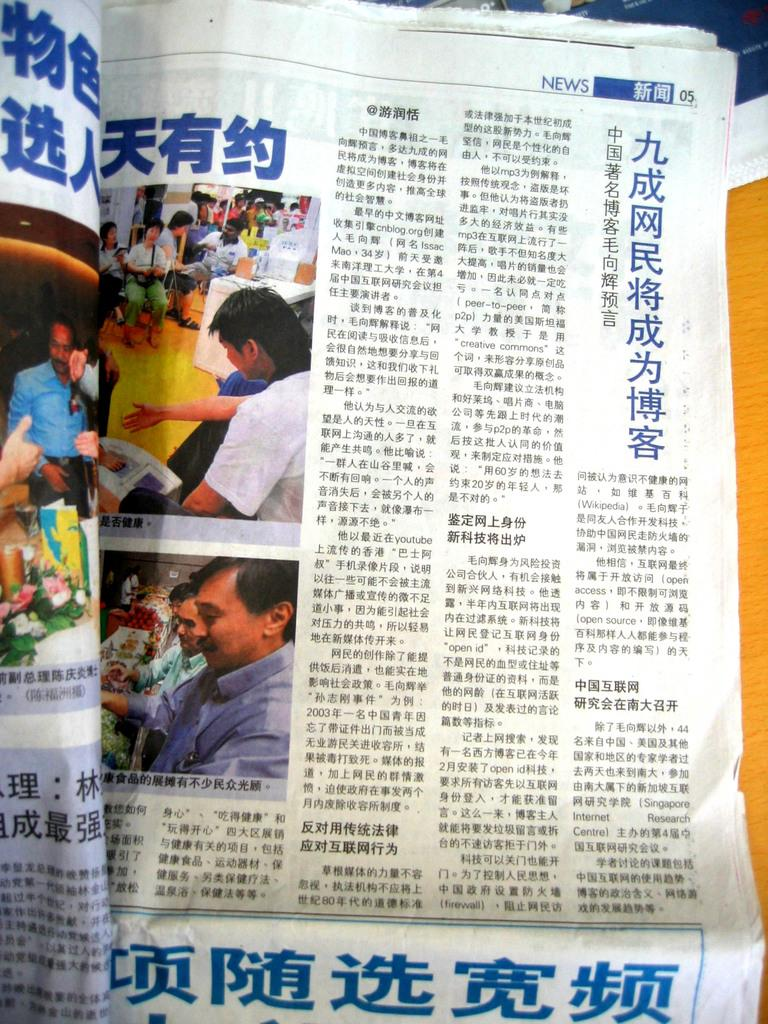What type of reading material is present in the image? There are newspapers in the image. What can be found within the newspapers? The newspapers contain text and pictures. What type of tooth can be seen in the image? There is no tooth present in the image; it features newspapers with text and pictures. What musical instrument is being played in the image? There is no musical instrument being played in the image; it features newspapers with text and pictures. 